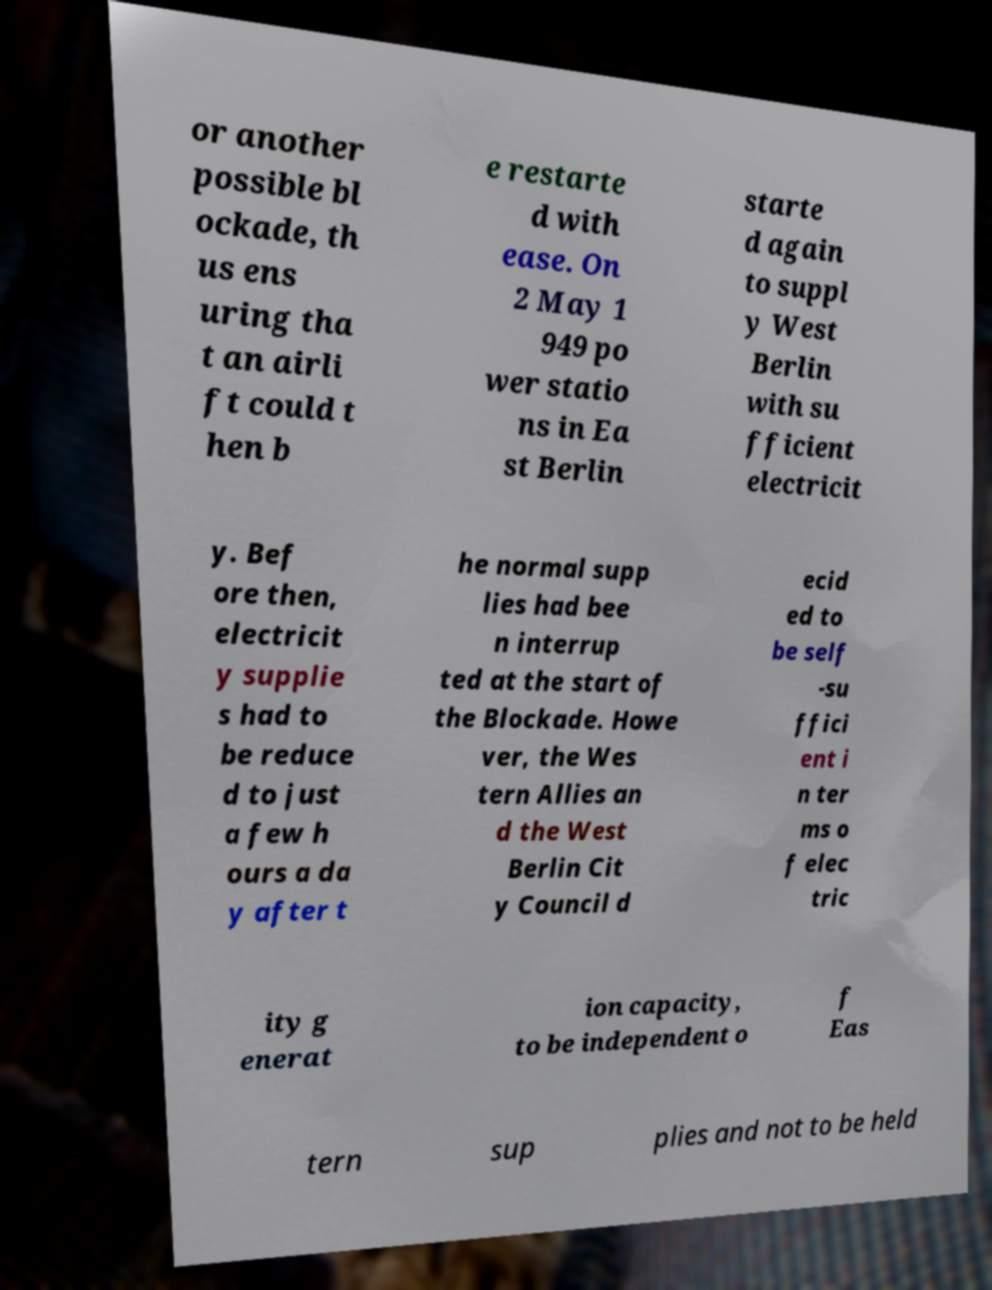Please identify and transcribe the text found in this image. or another possible bl ockade, th us ens uring tha t an airli ft could t hen b e restarte d with ease. On 2 May 1 949 po wer statio ns in Ea st Berlin starte d again to suppl y West Berlin with su fficient electricit y. Bef ore then, electricit y supplie s had to be reduce d to just a few h ours a da y after t he normal supp lies had bee n interrup ted at the start of the Blockade. Howe ver, the Wes tern Allies an d the West Berlin Cit y Council d ecid ed to be self -su ffici ent i n ter ms o f elec tric ity g enerat ion capacity, to be independent o f Eas tern sup plies and not to be held 